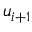<formula> <loc_0><loc_0><loc_500><loc_500>u _ { i + 1 }</formula> 